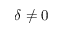<formula> <loc_0><loc_0><loc_500><loc_500>\delta \neq 0</formula> 